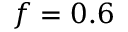<formula> <loc_0><loc_0><loc_500><loc_500>f = 0 . 6</formula> 